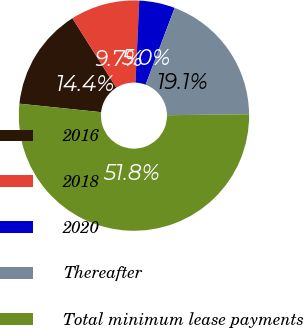Convert chart. <chart><loc_0><loc_0><loc_500><loc_500><pie_chart><fcel>2016<fcel>2018<fcel>2020<fcel>Thereafter<fcel>Total minimum lease payments<nl><fcel>14.38%<fcel>9.7%<fcel>5.02%<fcel>19.06%<fcel>51.84%<nl></chart> 